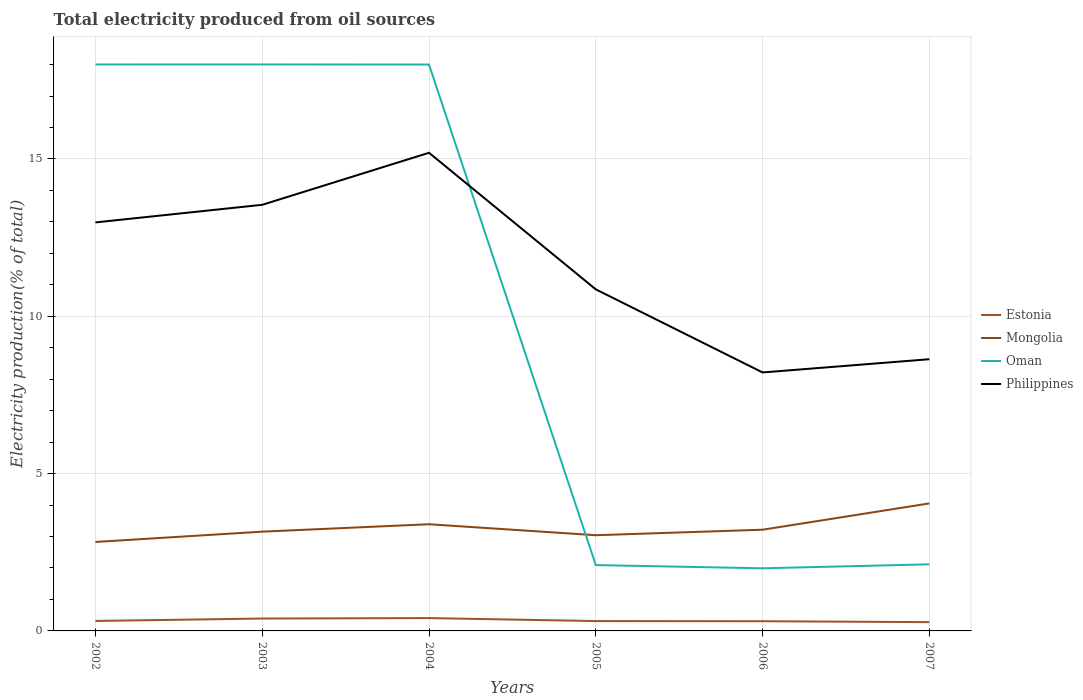How many different coloured lines are there?
Offer a very short reply. 4. Does the line corresponding to Mongolia intersect with the line corresponding to Philippines?
Offer a very short reply. No. Is the number of lines equal to the number of legend labels?
Offer a terse response. Yes. Across all years, what is the maximum total electricity produced in Philippines?
Your response must be concise. 8.22. What is the total total electricity produced in Mongolia in the graph?
Offer a very short reply. -1.01. What is the difference between the highest and the second highest total electricity produced in Oman?
Offer a very short reply. 16.01. How many lines are there?
Your response must be concise. 4. How many years are there in the graph?
Offer a very short reply. 6. How many legend labels are there?
Offer a very short reply. 4. How are the legend labels stacked?
Your response must be concise. Vertical. What is the title of the graph?
Your response must be concise. Total electricity produced from oil sources. What is the label or title of the Y-axis?
Provide a short and direct response. Electricity production(% of total). What is the Electricity production(% of total) in Estonia in 2002?
Your answer should be compact. 0.32. What is the Electricity production(% of total) in Mongolia in 2002?
Provide a short and direct response. 2.83. What is the Electricity production(% of total) of Oman in 2002?
Give a very brief answer. 18. What is the Electricity production(% of total) of Philippines in 2002?
Offer a terse response. 12.98. What is the Electricity production(% of total) in Estonia in 2003?
Your answer should be very brief. 0.39. What is the Electricity production(% of total) of Mongolia in 2003?
Offer a very short reply. 3.15. What is the Electricity production(% of total) in Oman in 2003?
Offer a terse response. 18. What is the Electricity production(% of total) in Philippines in 2003?
Your answer should be compact. 13.54. What is the Electricity production(% of total) of Estonia in 2004?
Ensure brevity in your answer.  0.41. What is the Electricity production(% of total) of Mongolia in 2004?
Your answer should be very brief. 3.39. What is the Electricity production(% of total) of Oman in 2004?
Offer a terse response. 18. What is the Electricity production(% of total) in Philippines in 2004?
Your answer should be compact. 15.2. What is the Electricity production(% of total) in Estonia in 2005?
Give a very brief answer. 0.31. What is the Electricity production(% of total) in Mongolia in 2005?
Your answer should be compact. 3.04. What is the Electricity production(% of total) in Oman in 2005?
Keep it short and to the point. 2.09. What is the Electricity production(% of total) of Philippines in 2005?
Provide a short and direct response. 10.86. What is the Electricity production(% of total) of Estonia in 2006?
Ensure brevity in your answer.  0.31. What is the Electricity production(% of total) of Mongolia in 2006?
Your answer should be very brief. 3.22. What is the Electricity production(% of total) of Oman in 2006?
Provide a short and direct response. 1.99. What is the Electricity production(% of total) of Philippines in 2006?
Your response must be concise. 8.22. What is the Electricity production(% of total) of Estonia in 2007?
Provide a succinct answer. 0.28. What is the Electricity production(% of total) of Mongolia in 2007?
Your answer should be compact. 4.05. What is the Electricity production(% of total) in Oman in 2007?
Make the answer very short. 2.12. What is the Electricity production(% of total) in Philippines in 2007?
Ensure brevity in your answer.  8.64. Across all years, what is the maximum Electricity production(% of total) of Estonia?
Provide a short and direct response. 0.41. Across all years, what is the maximum Electricity production(% of total) of Mongolia?
Provide a short and direct response. 4.05. Across all years, what is the maximum Electricity production(% of total) of Oman?
Offer a terse response. 18. Across all years, what is the maximum Electricity production(% of total) in Philippines?
Give a very brief answer. 15.2. Across all years, what is the minimum Electricity production(% of total) of Estonia?
Make the answer very short. 0.28. Across all years, what is the minimum Electricity production(% of total) of Mongolia?
Provide a succinct answer. 2.83. Across all years, what is the minimum Electricity production(% of total) in Oman?
Provide a succinct answer. 1.99. Across all years, what is the minimum Electricity production(% of total) in Philippines?
Give a very brief answer. 8.22. What is the total Electricity production(% of total) of Estonia in the graph?
Offer a terse response. 2.02. What is the total Electricity production(% of total) of Mongolia in the graph?
Provide a short and direct response. 19.68. What is the total Electricity production(% of total) in Oman in the graph?
Your answer should be compact. 60.21. What is the total Electricity production(% of total) of Philippines in the graph?
Your answer should be very brief. 69.43. What is the difference between the Electricity production(% of total) of Estonia in 2002 and that in 2003?
Provide a short and direct response. -0.08. What is the difference between the Electricity production(% of total) in Mongolia in 2002 and that in 2003?
Keep it short and to the point. -0.33. What is the difference between the Electricity production(% of total) in Oman in 2002 and that in 2003?
Keep it short and to the point. -0. What is the difference between the Electricity production(% of total) of Philippines in 2002 and that in 2003?
Provide a short and direct response. -0.56. What is the difference between the Electricity production(% of total) of Estonia in 2002 and that in 2004?
Your answer should be very brief. -0.09. What is the difference between the Electricity production(% of total) of Mongolia in 2002 and that in 2004?
Your answer should be very brief. -0.56. What is the difference between the Electricity production(% of total) of Oman in 2002 and that in 2004?
Give a very brief answer. 0. What is the difference between the Electricity production(% of total) in Philippines in 2002 and that in 2004?
Keep it short and to the point. -2.21. What is the difference between the Electricity production(% of total) in Estonia in 2002 and that in 2005?
Provide a short and direct response. 0. What is the difference between the Electricity production(% of total) in Mongolia in 2002 and that in 2005?
Your answer should be very brief. -0.21. What is the difference between the Electricity production(% of total) of Oman in 2002 and that in 2005?
Make the answer very short. 15.91. What is the difference between the Electricity production(% of total) in Philippines in 2002 and that in 2005?
Offer a terse response. 2.13. What is the difference between the Electricity production(% of total) in Estonia in 2002 and that in 2006?
Make the answer very short. 0.01. What is the difference between the Electricity production(% of total) in Mongolia in 2002 and that in 2006?
Your response must be concise. -0.39. What is the difference between the Electricity production(% of total) of Oman in 2002 and that in 2006?
Your response must be concise. 16.01. What is the difference between the Electricity production(% of total) in Philippines in 2002 and that in 2006?
Provide a short and direct response. 4.77. What is the difference between the Electricity production(% of total) of Estonia in 2002 and that in 2007?
Give a very brief answer. 0.04. What is the difference between the Electricity production(% of total) of Mongolia in 2002 and that in 2007?
Your response must be concise. -1.23. What is the difference between the Electricity production(% of total) of Oman in 2002 and that in 2007?
Offer a very short reply. 15.89. What is the difference between the Electricity production(% of total) of Philippines in 2002 and that in 2007?
Make the answer very short. 4.35. What is the difference between the Electricity production(% of total) of Estonia in 2003 and that in 2004?
Make the answer very short. -0.01. What is the difference between the Electricity production(% of total) in Mongolia in 2003 and that in 2004?
Offer a terse response. -0.24. What is the difference between the Electricity production(% of total) of Oman in 2003 and that in 2004?
Provide a short and direct response. 0. What is the difference between the Electricity production(% of total) in Philippines in 2003 and that in 2004?
Provide a short and direct response. -1.65. What is the difference between the Electricity production(% of total) of Estonia in 2003 and that in 2005?
Make the answer very short. 0.08. What is the difference between the Electricity production(% of total) of Mongolia in 2003 and that in 2005?
Keep it short and to the point. 0.11. What is the difference between the Electricity production(% of total) of Oman in 2003 and that in 2005?
Give a very brief answer. 15.91. What is the difference between the Electricity production(% of total) of Philippines in 2003 and that in 2005?
Give a very brief answer. 2.69. What is the difference between the Electricity production(% of total) of Estonia in 2003 and that in 2006?
Offer a very short reply. 0.09. What is the difference between the Electricity production(% of total) in Mongolia in 2003 and that in 2006?
Your answer should be compact. -0.06. What is the difference between the Electricity production(% of total) of Oman in 2003 and that in 2006?
Keep it short and to the point. 16.01. What is the difference between the Electricity production(% of total) of Philippines in 2003 and that in 2006?
Ensure brevity in your answer.  5.33. What is the difference between the Electricity production(% of total) of Estonia in 2003 and that in 2007?
Your answer should be compact. 0.11. What is the difference between the Electricity production(% of total) in Mongolia in 2003 and that in 2007?
Give a very brief answer. -0.9. What is the difference between the Electricity production(% of total) in Oman in 2003 and that in 2007?
Offer a terse response. 15.89. What is the difference between the Electricity production(% of total) of Philippines in 2003 and that in 2007?
Keep it short and to the point. 4.91. What is the difference between the Electricity production(% of total) of Estonia in 2004 and that in 2005?
Offer a terse response. 0.09. What is the difference between the Electricity production(% of total) in Mongolia in 2004 and that in 2005?
Your response must be concise. 0.35. What is the difference between the Electricity production(% of total) in Oman in 2004 and that in 2005?
Provide a short and direct response. 15.91. What is the difference between the Electricity production(% of total) in Philippines in 2004 and that in 2005?
Keep it short and to the point. 4.34. What is the difference between the Electricity production(% of total) in Estonia in 2004 and that in 2006?
Your answer should be very brief. 0.1. What is the difference between the Electricity production(% of total) in Mongolia in 2004 and that in 2006?
Provide a succinct answer. 0.17. What is the difference between the Electricity production(% of total) of Oman in 2004 and that in 2006?
Your answer should be very brief. 16.01. What is the difference between the Electricity production(% of total) in Philippines in 2004 and that in 2006?
Keep it short and to the point. 6.98. What is the difference between the Electricity production(% of total) of Estonia in 2004 and that in 2007?
Give a very brief answer. 0.13. What is the difference between the Electricity production(% of total) in Mongolia in 2004 and that in 2007?
Your response must be concise. -0.66. What is the difference between the Electricity production(% of total) in Oman in 2004 and that in 2007?
Your answer should be compact. 15.88. What is the difference between the Electricity production(% of total) of Philippines in 2004 and that in 2007?
Ensure brevity in your answer.  6.56. What is the difference between the Electricity production(% of total) in Estonia in 2005 and that in 2006?
Your answer should be compact. 0.01. What is the difference between the Electricity production(% of total) in Mongolia in 2005 and that in 2006?
Offer a terse response. -0.17. What is the difference between the Electricity production(% of total) of Oman in 2005 and that in 2006?
Give a very brief answer. 0.1. What is the difference between the Electricity production(% of total) in Philippines in 2005 and that in 2006?
Provide a short and direct response. 2.64. What is the difference between the Electricity production(% of total) of Estonia in 2005 and that in 2007?
Keep it short and to the point. 0.03. What is the difference between the Electricity production(% of total) in Mongolia in 2005 and that in 2007?
Offer a very short reply. -1.01. What is the difference between the Electricity production(% of total) of Oman in 2005 and that in 2007?
Your response must be concise. -0.02. What is the difference between the Electricity production(% of total) in Philippines in 2005 and that in 2007?
Give a very brief answer. 2.22. What is the difference between the Electricity production(% of total) of Estonia in 2006 and that in 2007?
Offer a very short reply. 0.03. What is the difference between the Electricity production(% of total) of Mongolia in 2006 and that in 2007?
Give a very brief answer. -0.84. What is the difference between the Electricity production(% of total) of Oman in 2006 and that in 2007?
Provide a succinct answer. -0.13. What is the difference between the Electricity production(% of total) in Philippines in 2006 and that in 2007?
Your response must be concise. -0.42. What is the difference between the Electricity production(% of total) of Estonia in 2002 and the Electricity production(% of total) of Mongolia in 2003?
Offer a terse response. -2.84. What is the difference between the Electricity production(% of total) in Estonia in 2002 and the Electricity production(% of total) in Oman in 2003?
Your answer should be very brief. -17.69. What is the difference between the Electricity production(% of total) in Estonia in 2002 and the Electricity production(% of total) in Philippines in 2003?
Your response must be concise. -13.23. What is the difference between the Electricity production(% of total) in Mongolia in 2002 and the Electricity production(% of total) in Oman in 2003?
Your answer should be compact. -15.18. What is the difference between the Electricity production(% of total) of Mongolia in 2002 and the Electricity production(% of total) of Philippines in 2003?
Keep it short and to the point. -10.72. What is the difference between the Electricity production(% of total) of Oman in 2002 and the Electricity production(% of total) of Philippines in 2003?
Your answer should be compact. 4.46. What is the difference between the Electricity production(% of total) in Estonia in 2002 and the Electricity production(% of total) in Mongolia in 2004?
Provide a succinct answer. -3.07. What is the difference between the Electricity production(% of total) in Estonia in 2002 and the Electricity production(% of total) in Oman in 2004?
Provide a succinct answer. -17.68. What is the difference between the Electricity production(% of total) of Estonia in 2002 and the Electricity production(% of total) of Philippines in 2004?
Provide a succinct answer. -14.88. What is the difference between the Electricity production(% of total) of Mongolia in 2002 and the Electricity production(% of total) of Oman in 2004?
Provide a short and direct response. -15.17. What is the difference between the Electricity production(% of total) of Mongolia in 2002 and the Electricity production(% of total) of Philippines in 2004?
Make the answer very short. -12.37. What is the difference between the Electricity production(% of total) in Oman in 2002 and the Electricity production(% of total) in Philippines in 2004?
Ensure brevity in your answer.  2.81. What is the difference between the Electricity production(% of total) in Estonia in 2002 and the Electricity production(% of total) in Mongolia in 2005?
Make the answer very short. -2.73. What is the difference between the Electricity production(% of total) in Estonia in 2002 and the Electricity production(% of total) in Oman in 2005?
Give a very brief answer. -1.78. What is the difference between the Electricity production(% of total) in Estonia in 2002 and the Electricity production(% of total) in Philippines in 2005?
Give a very brief answer. -10.54. What is the difference between the Electricity production(% of total) in Mongolia in 2002 and the Electricity production(% of total) in Oman in 2005?
Your answer should be compact. 0.74. What is the difference between the Electricity production(% of total) in Mongolia in 2002 and the Electricity production(% of total) in Philippines in 2005?
Offer a terse response. -8.03. What is the difference between the Electricity production(% of total) in Oman in 2002 and the Electricity production(% of total) in Philippines in 2005?
Your answer should be compact. 7.15. What is the difference between the Electricity production(% of total) of Estonia in 2002 and the Electricity production(% of total) of Mongolia in 2006?
Your answer should be compact. -2.9. What is the difference between the Electricity production(% of total) in Estonia in 2002 and the Electricity production(% of total) in Oman in 2006?
Your answer should be very brief. -1.67. What is the difference between the Electricity production(% of total) in Estonia in 2002 and the Electricity production(% of total) in Philippines in 2006?
Offer a terse response. -7.9. What is the difference between the Electricity production(% of total) in Mongolia in 2002 and the Electricity production(% of total) in Oman in 2006?
Provide a succinct answer. 0.84. What is the difference between the Electricity production(% of total) in Mongolia in 2002 and the Electricity production(% of total) in Philippines in 2006?
Offer a terse response. -5.39. What is the difference between the Electricity production(% of total) in Oman in 2002 and the Electricity production(% of total) in Philippines in 2006?
Ensure brevity in your answer.  9.79. What is the difference between the Electricity production(% of total) of Estonia in 2002 and the Electricity production(% of total) of Mongolia in 2007?
Give a very brief answer. -3.74. What is the difference between the Electricity production(% of total) in Estonia in 2002 and the Electricity production(% of total) in Oman in 2007?
Make the answer very short. -1.8. What is the difference between the Electricity production(% of total) of Estonia in 2002 and the Electricity production(% of total) of Philippines in 2007?
Give a very brief answer. -8.32. What is the difference between the Electricity production(% of total) of Mongolia in 2002 and the Electricity production(% of total) of Oman in 2007?
Ensure brevity in your answer.  0.71. What is the difference between the Electricity production(% of total) in Mongolia in 2002 and the Electricity production(% of total) in Philippines in 2007?
Your answer should be compact. -5.81. What is the difference between the Electricity production(% of total) in Oman in 2002 and the Electricity production(% of total) in Philippines in 2007?
Provide a short and direct response. 9.37. What is the difference between the Electricity production(% of total) in Estonia in 2003 and the Electricity production(% of total) in Mongolia in 2004?
Your answer should be compact. -3. What is the difference between the Electricity production(% of total) in Estonia in 2003 and the Electricity production(% of total) in Oman in 2004?
Keep it short and to the point. -17.61. What is the difference between the Electricity production(% of total) of Estonia in 2003 and the Electricity production(% of total) of Philippines in 2004?
Provide a succinct answer. -14.8. What is the difference between the Electricity production(% of total) in Mongolia in 2003 and the Electricity production(% of total) in Oman in 2004?
Provide a succinct answer. -14.85. What is the difference between the Electricity production(% of total) of Mongolia in 2003 and the Electricity production(% of total) of Philippines in 2004?
Give a very brief answer. -12.04. What is the difference between the Electricity production(% of total) of Oman in 2003 and the Electricity production(% of total) of Philippines in 2004?
Your answer should be very brief. 2.81. What is the difference between the Electricity production(% of total) in Estonia in 2003 and the Electricity production(% of total) in Mongolia in 2005?
Provide a succinct answer. -2.65. What is the difference between the Electricity production(% of total) of Estonia in 2003 and the Electricity production(% of total) of Oman in 2005?
Give a very brief answer. -1.7. What is the difference between the Electricity production(% of total) of Estonia in 2003 and the Electricity production(% of total) of Philippines in 2005?
Ensure brevity in your answer.  -10.46. What is the difference between the Electricity production(% of total) in Mongolia in 2003 and the Electricity production(% of total) in Oman in 2005?
Your answer should be compact. 1.06. What is the difference between the Electricity production(% of total) of Mongolia in 2003 and the Electricity production(% of total) of Philippines in 2005?
Ensure brevity in your answer.  -7.7. What is the difference between the Electricity production(% of total) in Oman in 2003 and the Electricity production(% of total) in Philippines in 2005?
Give a very brief answer. 7.15. What is the difference between the Electricity production(% of total) in Estonia in 2003 and the Electricity production(% of total) in Mongolia in 2006?
Your answer should be very brief. -2.82. What is the difference between the Electricity production(% of total) of Estonia in 2003 and the Electricity production(% of total) of Oman in 2006?
Make the answer very short. -1.6. What is the difference between the Electricity production(% of total) of Estonia in 2003 and the Electricity production(% of total) of Philippines in 2006?
Ensure brevity in your answer.  -7.82. What is the difference between the Electricity production(% of total) of Mongolia in 2003 and the Electricity production(% of total) of Oman in 2006?
Make the answer very short. 1.16. What is the difference between the Electricity production(% of total) of Mongolia in 2003 and the Electricity production(% of total) of Philippines in 2006?
Offer a very short reply. -5.06. What is the difference between the Electricity production(% of total) in Oman in 2003 and the Electricity production(% of total) in Philippines in 2006?
Give a very brief answer. 9.79. What is the difference between the Electricity production(% of total) of Estonia in 2003 and the Electricity production(% of total) of Mongolia in 2007?
Your answer should be very brief. -3.66. What is the difference between the Electricity production(% of total) of Estonia in 2003 and the Electricity production(% of total) of Oman in 2007?
Offer a terse response. -1.72. What is the difference between the Electricity production(% of total) in Estonia in 2003 and the Electricity production(% of total) in Philippines in 2007?
Your answer should be very brief. -8.24. What is the difference between the Electricity production(% of total) of Mongolia in 2003 and the Electricity production(% of total) of Oman in 2007?
Keep it short and to the point. 1.04. What is the difference between the Electricity production(% of total) of Mongolia in 2003 and the Electricity production(% of total) of Philippines in 2007?
Offer a very short reply. -5.48. What is the difference between the Electricity production(% of total) of Oman in 2003 and the Electricity production(% of total) of Philippines in 2007?
Your answer should be very brief. 9.37. What is the difference between the Electricity production(% of total) of Estonia in 2004 and the Electricity production(% of total) of Mongolia in 2005?
Your answer should be compact. -2.63. What is the difference between the Electricity production(% of total) in Estonia in 2004 and the Electricity production(% of total) in Oman in 2005?
Offer a very short reply. -1.69. What is the difference between the Electricity production(% of total) of Estonia in 2004 and the Electricity production(% of total) of Philippines in 2005?
Keep it short and to the point. -10.45. What is the difference between the Electricity production(% of total) of Mongolia in 2004 and the Electricity production(% of total) of Oman in 2005?
Your answer should be compact. 1.3. What is the difference between the Electricity production(% of total) in Mongolia in 2004 and the Electricity production(% of total) in Philippines in 2005?
Offer a very short reply. -7.47. What is the difference between the Electricity production(% of total) in Oman in 2004 and the Electricity production(% of total) in Philippines in 2005?
Provide a short and direct response. 7.15. What is the difference between the Electricity production(% of total) in Estonia in 2004 and the Electricity production(% of total) in Mongolia in 2006?
Your answer should be compact. -2.81. What is the difference between the Electricity production(% of total) in Estonia in 2004 and the Electricity production(% of total) in Oman in 2006?
Offer a terse response. -1.58. What is the difference between the Electricity production(% of total) of Estonia in 2004 and the Electricity production(% of total) of Philippines in 2006?
Give a very brief answer. -7.81. What is the difference between the Electricity production(% of total) in Mongolia in 2004 and the Electricity production(% of total) in Oman in 2006?
Provide a short and direct response. 1.4. What is the difference between the Electricity production(% of total) in Mongolia in 2004 and the Electricity production(% of total) in Philippines in 2006?
Give a very brief answer. -4.82. What is the difference between the Electricity production(% of total) of Oman in 2004 and the Electricity production(% of total) of Philippines in 2006?
Your answer should be very brief. 9.79. What is the difference between the Electricity production(% of total) of Estonia in 2004 and the Electricity production(% of total) of Mongolia in 2007?
Provide a short and direct response. -3.65. What is the difference between the Electricity production(% of total) in Estonia in 2004 and the Electricity production(% of total) in Oman in 2007?
Offer a very short reply. -1.71. What is the difference between the Electricity production(% of total) in Estonia in 2004 and the Electricity production(% of total) in Philippines in 2007?
Offer a very short reply. -8.23. What is the difference between the Electricity production(% of total) of Mongolia in 2004 and the Electricity production(% of total) of Oman in 2007?
Offer a terse response. 1.27. What is the difference between the Electricity production(% of total) in Mongolia in 2004 and the Electricity production(% of total) in Philippines in 2007?
Offer a terse response. -5.25. What is the difference between the Electricity production(% of total) of Oman in 2004 and the Electricity production(% of total) of Philippines in 2007?
Make the answer very short. 9.37. What is the difference between the Electricity production(% of total) in Estonia in 2005 and the Electricity production(% of total) in Mongolia in 2006?
Your answer should be very brief. -2.9. What is the difference between the Electricity production(% of total) of Estonia in 2005 and the Electricity production(% of total) of Oman in 2006?
Offer a very short reply. -1.68. What is the difference between the Electricity production(% of total) of Estonia in 2005 and the Electricity production(% of total) of Philippines in 2006?
Your response must be concise. -7.9. What is the difference between the Electricity production(% of total) of Mongolia in 2005 and the Electricity production(% of total) of Oman in 2006?
Give a very brief answer. 1.05. What is the difference between the Electricity production(% of total) in Mongolia in 2005 and the Electricity production(% of total) in Philippines in 2006?
Give a very brief answer. -5.17. What is the difference between the Electricity production(% of total) in Oman in 2005 and the Electricity production(% of total) in Philippines in 2006?
Ensure brevity in your answer.  -6.12. What is the difference between the Electricity production(% of total) in Estonia in 2005 and the Electricity production(% of total) in Mongolia in 2007?
Ensure brevity in your answer.  -3.74. What is the difference between the Electricity production(% of total) in Estonia in 2005 and the Electricity production(% of total) in Oman in 2007?
Make the answer very short. -1.8. What is the difference between the Electricity production(% of total) of Estonia in 2005 and the Electricity production(% of total) of Philippines in 2007?
Offer a terse response. -8.32. What is the difference between the Electricity production(% of total) in Mongolia in 2005 and the Electricity production(% of total) in Oman in 2007?
Offer a very short reply. 0.93. What is the difference between the Electricity production(% of total) of Mongolia in 2005 and the Electricity production(% of total) of Philippines in 2007?
Your answer should be compact. -5.59. What is the difference between the Electricity production(% of total) in Oman in 2005 and the Electricity production(% of total) in Philippines in 2007?
Your answer should be compact. -6.54. What is the difference between the Electricity production(% of total) in Estonia in 2006 and the Electricity production(% of total) in Mongolia in 2007?
Your response must be concise. -3.74. What is the difference between the Electricity production(% of total) of Estonia in 2006 and the Electricity production(% of total) of Oman in 2007?
Keep it short and to the point. -1.81. What is the difference between the Electricity production(% of total) in Estonia in 2006 and the Electricity production(% of total) in Philippines in 2007?
Keep it short and to the point. -8.33. What is the difference between the Electricity production(% of total) in Mongolia in 2006 and the Electricity production(% of total) in Oman in 2007?
Provide a short and direct response. 1.1. What is the difference between the Electricity production(% of total) of Mongolia in 2006 and the Electricity production(% of total) of Philippines in 2007?
Your answer should be very brief. -5.42. What is the difference between the Electricity production(% of total) in Oman in 2006 and the Electricity production(% of total) in Philippines in 2007?
Provide a succinct answer. -6.65. What is the average Electricity production(% of total) in Estonia per year?
Keep it short and to the point. 0.34. What is the average Electricity production(% of total) in Mongolia per year?
Your response must be concise. 3.28. What is the average Electricity production(% of total) in Oman per year?
Give a very brief answer. 10.04. What is the average Electricity production(% of total) in Philippines per year?
Offer a terse response. 11.57. In the year 2002, what is the difference between the Electricity production(% of total) in Estonia and Electricity production(% of total) in Mongolia?
Provide a short and direct response. -2.51. In the year 2002, what is the difference between the Electricity production(% of total) of Estonia and Electricity production(% of total) of Oman?
Ensure brevity in your answer.  -17.69. In the year 2002, what is the difference between the Electricity production(% of total) of Estonia and Electricity production(% of total) of Philippines?
Provide a succinct answer. -12.67. In the year 2002, what is the difference between the Electricity production(% of total) of Mongolia and Electricity production(% of total) of Oman?
Your answer should be very brief. -15.18. In the year 2002, what is the difference between the Electricity production(% of total) in Mongolia and Electricity production(% of total) in Philippines?
Give a very brief answer. -10.16. In the year 2002, what is the difference between the Electricity production(% of total) of Oman and Electricity production(% of total) of Philippines?
Give a very brief answer. 5.02. In the year 2003, what is the difference between the Electricity production(% of total) of Estonia and Electricity production(% of total) of Mongolia?
Provide a succinct answer. -2.76. In the year 2003, what is the difference between the Electricity production(% of total) of Estonia and Electricity production(% of total) of Oman?
Make the answer very short. -17.61. In the year 2003, what is the difference between the Electricity production(% of total) of Estonia and Electricity production(% of total) of Philippines?
Provide a short and direct response. -13.15. In the year 2003, what is the difference between the Electricity production(% of total) of Mongolia and Electricity production(% of total) of Oman?
Keep it short and to the point. -14.85. In the year 2003, what is the difference between the Electricity production(% of total) of Mongolia and Electricity production(% of total) of Philippines?
Ensure brevity in your answer.  -10.39. In the year 2003, what is the difference between the Electricity production(% of total) of Oman and Electricity production(% of total) of Philippines?
Offer a terse response. 4.46. In the year 2004, what is the difference between the Electricity production(% of total) of Estonia and Electricity production(% of total) of Mongolia?
Make the answer very short. -2.98. In the year 2004, what is the difference between the Electricity production(% of total) in Estonia and Electricity production(% of total) in Oman?
Your response must be concise. -17.59. In the year 2004, what is the difference between the Electricity production(% of total) of Estonia and Electricity production(% of total) of Philippines?
Your response must be concise. -14.79. In the year 2004, what is the difference between the Electricity production(% of total) of Mongolia and Electricity production(% of total) of Oman?
Give a very brief answer. -14.61. In the year 2004, what is the difference between the Electricity production(% of total) of Mongolia and Electricity production(% of total) of Philippines?
Make the answer very short. -11.81. In the year 2004, what is the difference between the Electricity production(% of total) of Oman and Electricity production(% of total) of Philippines?
Offer a very short reply. 2.8. In the year 2005, what is the difference between the Electricity production(% of total) of Estonia and Electricity production(% of total) of Mongolia?
Your answer should be compact. -2.73. In the year 2005, what is the difference between the Electricity production(% of total) of Estonia and Electricity production(% of total) of Oman?
Your response must be concise. -1.78. In the year 2005, what is the difference between the Electricity production(% of total) of Estonia and Electricity production(% of total) of Philippines?
Give a very brief answer. -10.54. In the year 2005, what is the difference between the Electricity production(% of total) in Mongolia and Electricity production(% of total) in Oman?
Offer a terse response. 0.95. In the year 2005, what is the difference between the Electricity production(% of total) of Mongolia and Electricity production(% of total) of Philippines?
Provide a short and direct response. -7.81. In the year 2005, what is the difference between the Electricity production(% of total) in Oman and Electricity production(% of total) in Philippines?
Ensure brevity in your answer.  -8.76. In the year 2006, what is the difference between the Electricity production(% of total) in Estonia and Electricity production(% of total) in Mongolia?
Your response must be concise. -2.91. In the year 2006, what is the difference between the Electricity production(% of total) of Estonia and Electricity production(% of total) of Oman?
Your response must be concise. -1.68. In the year 2006, what is the difference between the Electricity production(% of total) in Estonia and Electricity production(% of total) in Philippines?
Offer a terse response. -7.91. In the year 2006, what is the difference between the Electricity production(% of total) in Mongolia and Electricity production(% of total) in Oman?
Ensure brevity in your answer.  1.23. In the year 2006, what is the difference between the Electricity production(% of total) of Mongolia and Electricity production(% of total) of Philippines?
Your answer should be compact. -5. In the year 2006, what is the difference between the Electricity production(% of total) of Oman and Electricity production(% of total) of Philippines?
Make the answer very short. -6.22. In the year 2007, what is the difference between the Electricity production(% of total) in Estonia and Electricity production(% of total) in Mongolia?
Make the answer very short. -3.77. In the year 2007, what is the difference between the Electricity production(% of total) of Estonia and Electricity production(% of total) of Oman?
Your answer should be very brief. -1.84. In the year 2007, what is the difference between the Electricity production(% of total) in Estonia and Electricity production(% of total) in Philippines?
Provide a succinct answer. -8.36. In the year 2007, what is the difference between the Electricity production(% of total) in Mongolia and Electricity production(% of total) in Oman?
Make the answer very short. 1.94. In the year 2007, what is the difference between the Electricity production(% of total) in Mongolia and Electricity production(% of total) in Philippines?
Offer a very short reply. -4.58. In the year 2007, what is the difference between the Electricity production(% of total) in Oman and Electricity production(% of total) in Philippines?
Your answer should be compact. -6.52. What is the ratio of the Electricity production(% of total) of Estonia in 2002 to that in 2003?
Offer a very short reply. 0.8. What is the ratio of the Electricity production(% of total) in Mongolia in 2002 to that in 2003?
Offer a very short reply. 0.9. What is the ratio of the Electricity production(% of total) in Philippines in 2002 to that in 2003?
Provide a short and direct response. 0.96. What is the ratio of the Electricity production(% of total) in Estonia in 2002 to that in 2004?
Ensure brevity in your answer.  0.78. What is the ratio of the Electricity production(% of total) of Mongolia in 2002 to that in 2004?
Your answer should be compact. 0.83. What is the ratio of the Electricity production(% of total) of Oman in 2002 to that in 2004?
Offer a terse response. 1. What is the ratio of the Electricity production(% of total) in Philippines in 2002 to that in 2004?
Provide a succinct answer. 0.85. What is the ratio of the Electricity production(% of total) of Estonia in 2002 to that in 2005?
Make the answer very short. 1.01. What is the ratio of the Electricity production(% of total) in Mongolia in 2002 to that in 2005?
Your response must be concise. 0.93. What is the ratio of the Electricity production(% of total) in Oman in 2002 to that in 2005?
Offer a very short reply. 8.6. What is the ratio of the Electricity production(% of total) of Philippines in 2002 to that in 2005?
Give a very brief answer. 1.2. What is the ratio of the Electricity production(% of total) in Estonia in 2002 to that in 2006?
Keep it short and to the point. 1.03. What is the ratio of the Electricity production(% of total) in Mongolia in 2002 to that in 2006?
Ensure brevity in your answer.  0.88. What is the ratio of the Electricity production(% of total) of Oman in 2002 to that in 2006?
Your answer should be very brief. 9.04. What is the ratio of the Electricity production(% of total) of Philippines in 2002 to that in 2006?
Your answer should be compact. 1.58. What is the ratio of the Electricity production(% of total) of Estonia in 2002 to that in 2007?
Keep it short and to the point. 1.14. What is the ratio of the Electricity production(% of total) of Mongolia in 2002 to that in 2007?
Provide a succinct answer. 0.7. What is the ratio of the Electricity production(% of total) of Oman in 2002 to that in 2007?
Give a very brief answer. 8.51. What is the ratio of the Electricity production(% of total) of Philippines in 2002 to that in 2007?
Your answer should be very brief. 1.5. What is the ratio of the Electricity production(% of total) of Estonia in 2003 to that in 2004?
Your response must be concise. 0.97. What is the ratio of the Electricity production(% of total) in Mongolia in 2003 to that in 2004?
Offer a terse response. 0.93. What is the ratio of the Electricity production(% of total) of Philippines in 2003 to that in 2004?
Offer a very short reply. 0.89. What is the ratio of the Electricity production(% of total) in Estonia in 2003 to that in 2005?
Offer a terse response. 1.26. What is the ratio of the Electricity production(% of total) in Mongolia in 2003 to that in 2005?
Offer a very short reply. 1.04. What is the ratio of the Electricity production(% of total) in Oman in 2003 to that in 2005?
Your answer should be very brief. 8.6. What is the ratio of the Electricity production(% of total) in Philippines in 2003 to that in 2005?
Your response must be concise. 1.25. What is the ratio of the Electricity production(% of total) in Estonia in 2003 to that in 2006?
Provide a short and direct response. 1.28. What is the ratio of the Electricity production(% of total) of Mongolia in 2003 to that in 2006?
Give a very brief answer. 0.98. What is the ratio of the Electricity production(% of total) of Oman in 2003 to that in 2006?
Provide a short and direct response. 9.04. What is the ratio of the Electricity production(% of total) of Philippines in 2003 to that in 2006?
Provide a short and direct response. 1.65. What is the ratio of the Electricity production(% of total) in Estonia in 2003 to that in 2007?
Make the answer very short. 1.41. What is the ratio of the Electricity production(% of total) in Mongolia in 2003 to that in 2007?
Your response must be concise. 0.78. What is the ratio of the Electricity production(% of total) in Oman in 2003 to that in 2007?
Your response must be concise. 8.51. What is the ratio of the Electricity production(% of total) in Philippines in 2003 to that in 2007?
Make the answer very short. 1.57. What is the ratio of the Electricity production(% of total) of Estonia in 2004 to that in 2005?
Offer a terse response. 1.3. What is the ratio of the Electricity production(% of total) in Mongolia in 2004 to that in 2005?
Make the answer very short. 1.11. What is the ratio of the Electricity production(% of total) of Oman in 2004 to that in 2005?
Provide a short and direct response. 8.6. What is the ratio of the Electricity production(% of total) in Philippines in 2004 to that in 2005?
Keep it short and to the point. 1.4. What is the ratio of the Electricity production(% of total) in Estonia in 2004 to that in 2006?
Offer a very short reply. 1.32. What is the ratio of the Electricity production(% of total) in Mongolia in 2004 to that in 2006?
Your response must be concise. 1.05. What is the ratio of the Electricity production(% of total) of Oman in 2004 to that in 2006?
Provide a short and direct response. 9.04. What is the ratio of the Electricity production(% of total) in Philippines in 2004 to that in 2006?
Keep it short and to the point. 1.85. What is the ratio of the Electricity production(% of total) of Estonia in 2004 to that in 2007?
Your response must be concise. 1.46. What is the ratio of the Electricity production(% of total) in Mongolia in 2004 to that in 2007?
Keep it short and to the point. 0.84. What is the ratio of the Electricity production(% of total) in Oman in 2004 to that in 2007?
Offer a terse response. 8.5. What is the ratio of the Electricity production(% of total) in Philippines in 2004 to that in 2007?
Your answer should be very brief. 1.76. What is the ratio of the Electricity production(% of total) in Estonia in 2005 to that in 2006?
Offer a terse response. 1.02. What is the ratio of the Electricity production(% of total) of Mongolia in 2005 to that in 2006?
Offer a terse response. 0.95. What is the ratio of the Electricity production(% of total) in Oman in 2005 to that in 2006?
Provide a short and direct response. 1.05. What is the ratio of the Electricity production(% of total) of Philippines in 2005 to that in 2006?
Give a very brief answer. 1.32. What is the ratio of the Electricity production(% of total) in Estonia in 2005 to that in 2007?
Your answer should be compact. 1.12. What is the ratio of the Electricity production(% of total) in Mongolia in 2005 to that in 2007?
Provide a short and direct response. 0.75. What is the ratio of the Electricity production(% of total) of Oman in 2005 to that in 2007?
Ensure brevity in your answer.  0.99. What is the ratio of the Electricity production(% of total) of Philippines in 2005 to that in 2007?
Your answer should be very brief. 1.26. What is the ratio of the Electricity production(% of total) in Estonia in 2006 to that in 2007?
Your answer should be very brief. 1.11. What is the ratio of the Electricity production(% of total) of Mongolia in 2006 to that in 2007?
Provide a short and direct response. 0.79. What is the ratio of the Electricity production(% of total) of Oman in 2006 to that in 2007?
Your response must be concise. 0.94. What is the ratio of the Electricity production(% of total) of Philippines in 2006 to that in 2007?
Your response must be concise. 0.95. What is the difference between the highest and the second highest Electricity production(% of total) in Estonia?
Your answer should be very brief. 0.01. What is the difference between the highest and the second highest Electricity production(% of total) in Mongolia?
Your response must be concise. 0.66. What is the difference between the highest and the second highest Electricity production(% of total) of Philippines?
Your response must be concise. 1.65. What is the difference between the highest and the lowest Electricity production(% of total) of Estonia?
Your answer should be compact. 0.13. What is the difference between the highest and the lowest Electricity production(% of total) of Mongolia?
Make the answer very short. 1.23. What is the difference between the highest and the lowest Electricity production(% of total) of Oman?
Make the answer very short. 16.01. What is the difference between the highest and the lowest Electricity production(% of total) in Philippines?
Provide a succinct answer. 6.98. 